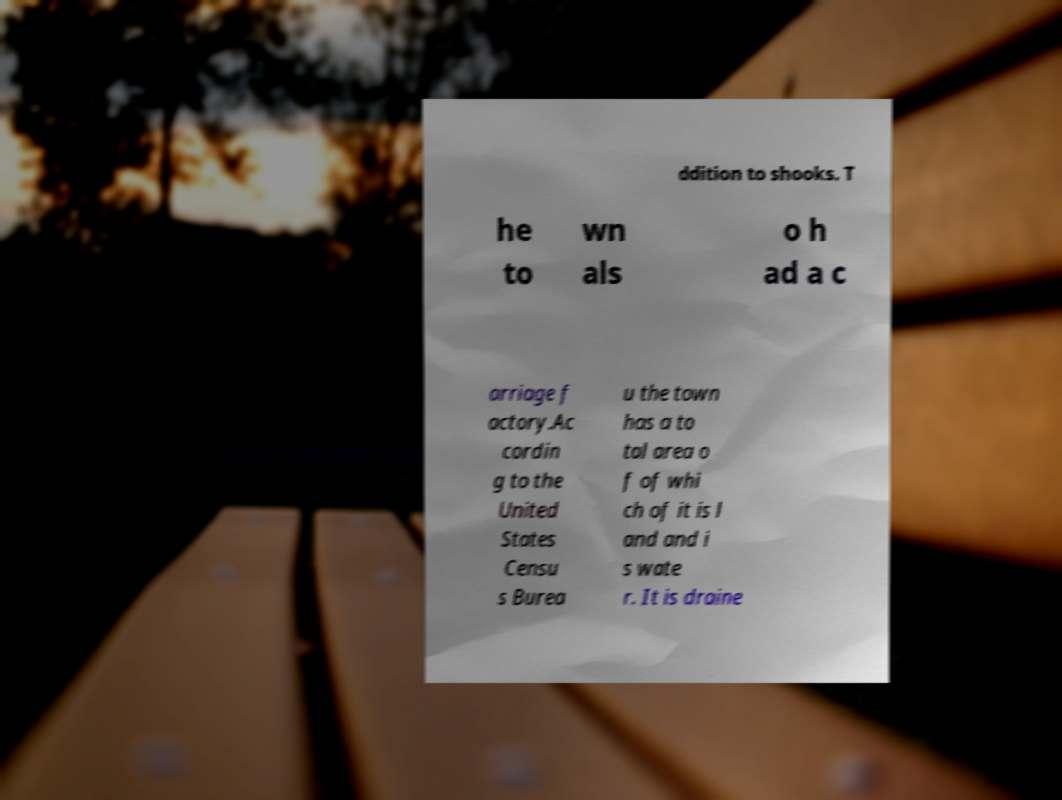For documentation purposes, I need the text within this image transcribed. Could you provide that? ddition to shooks. T he to wn als o h ad a c arriage f actory.Ac cordin g to the United States Censu s Burea u the town has a to tal area o f of whi ch of it is l and and i s wate r. It is draine 